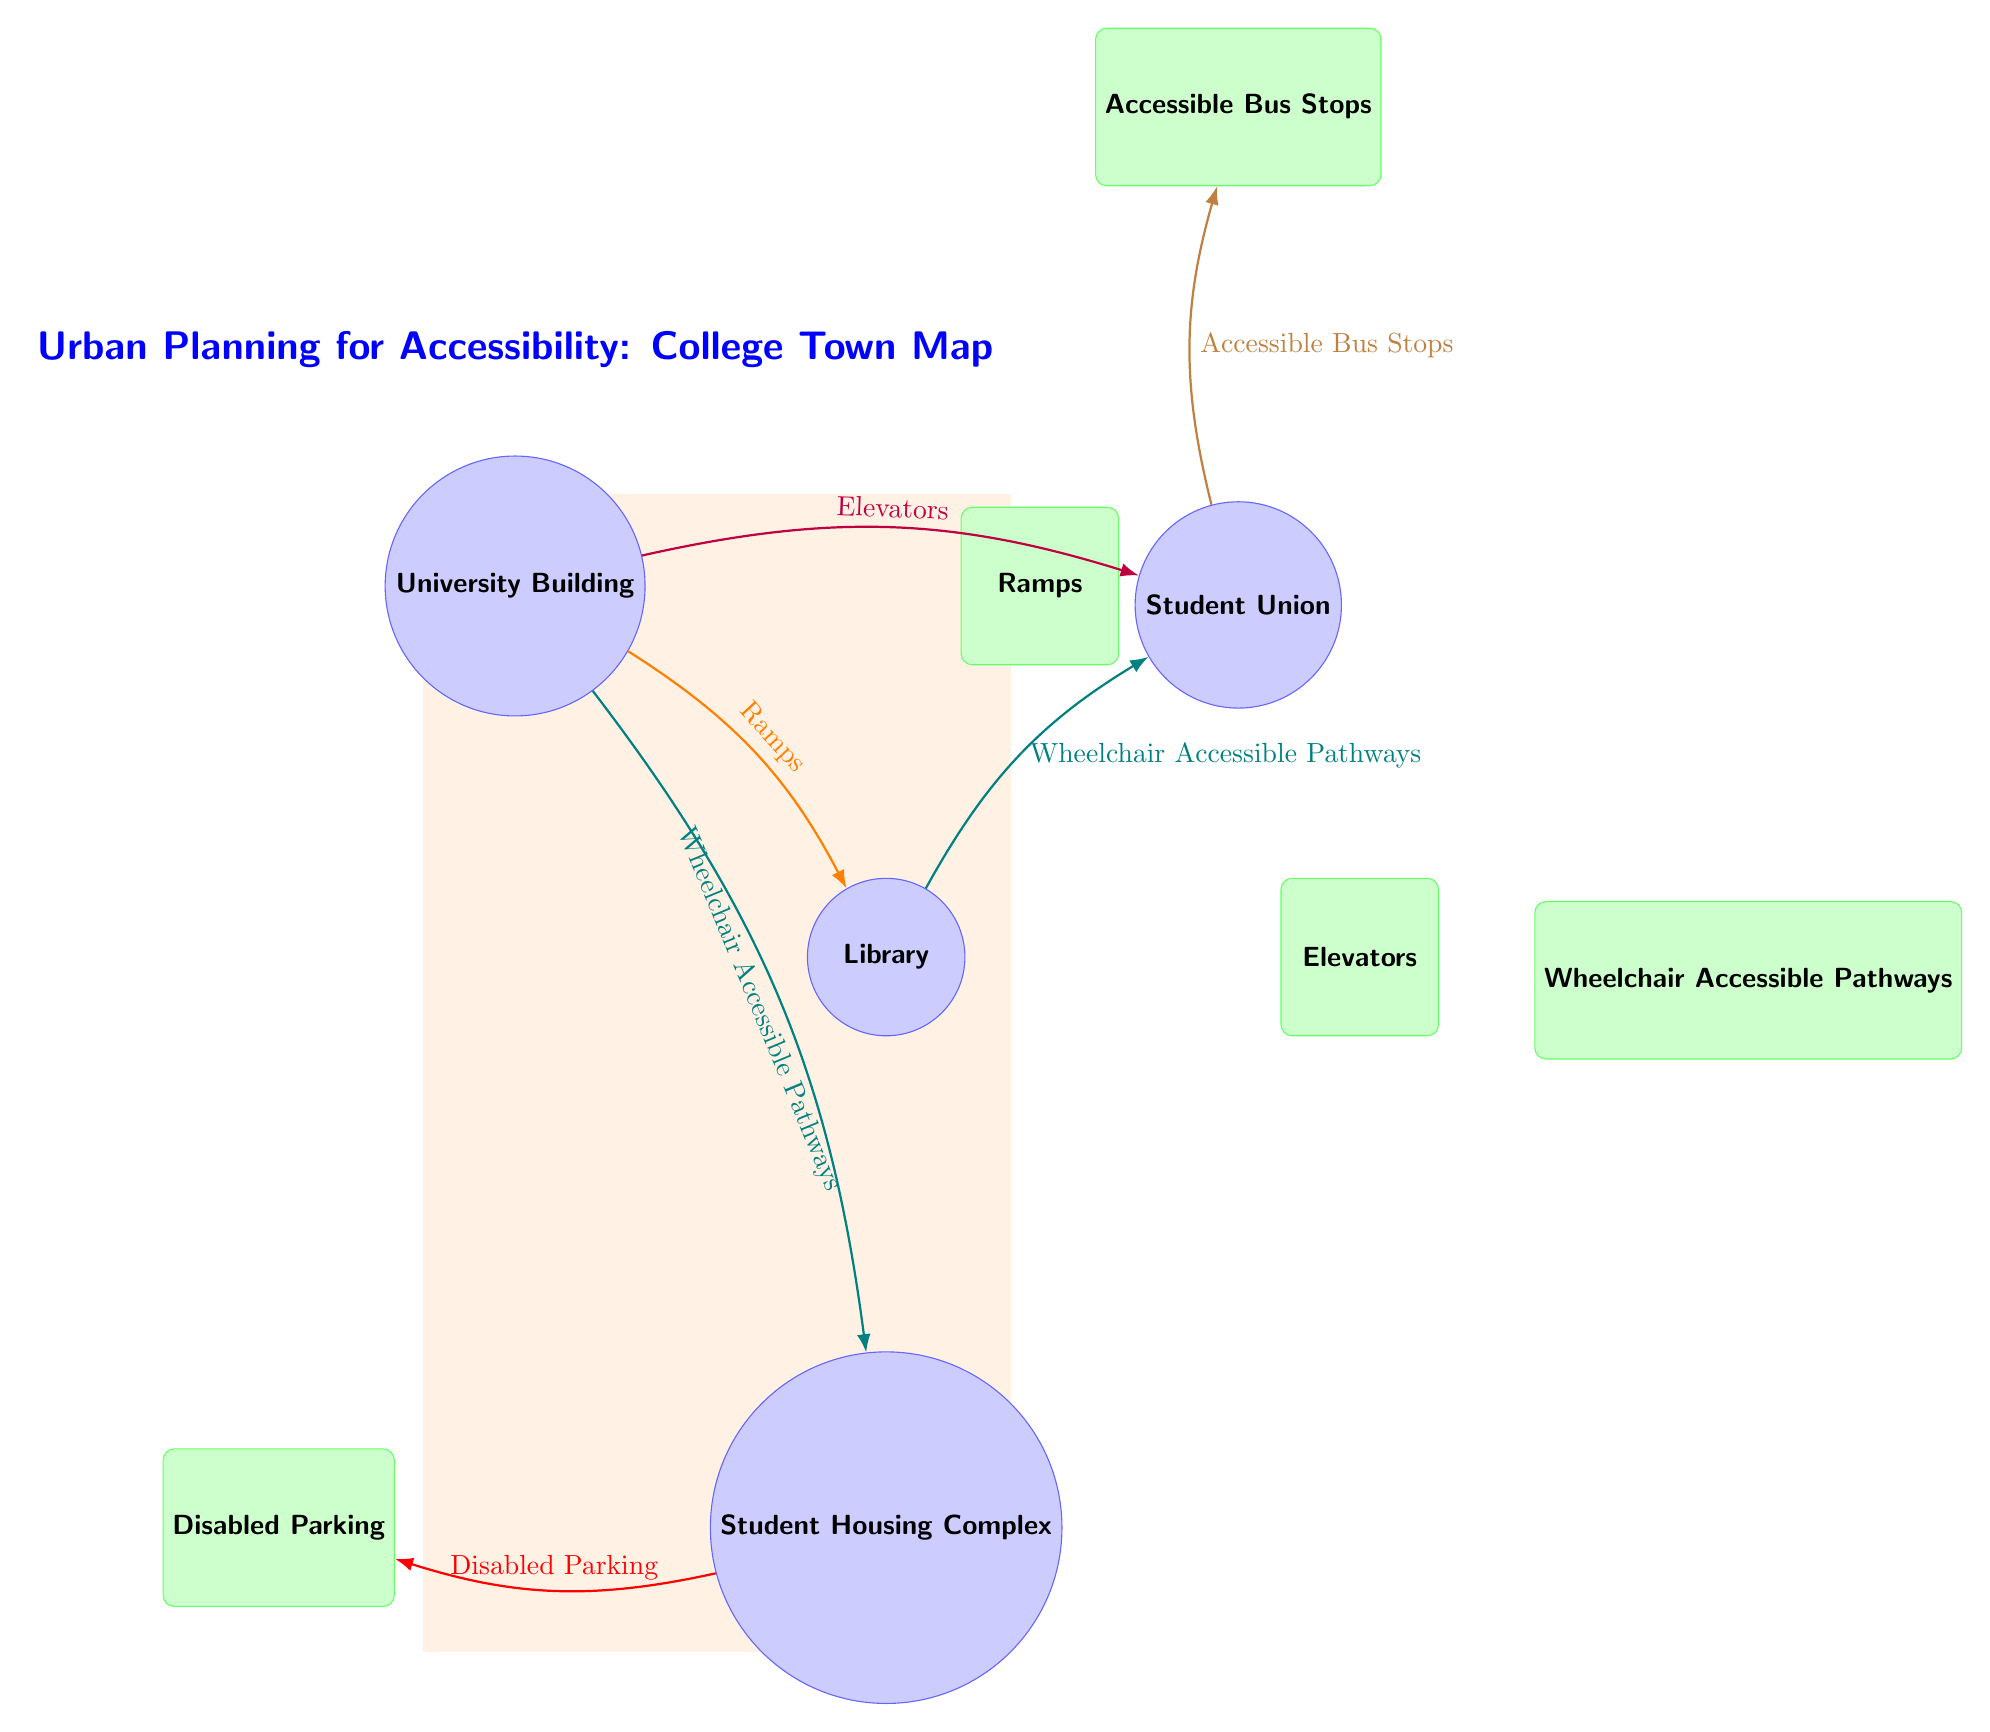What is the first location mentioned in the diagram? The first location node listed is the "University Building." This can be found at the top of the diagram as the initial node before any connections are drawn.
Answer: University Building How many locations are represented in the diagram? The diagram visually presents four distinct location nodes: University Building, Library, Student Union, and Student Housing Complex. By counting these nodes, we find there are four in total.
Answer: 4 What type of connection exists between the University Building and the Library? The connection from the University Building to the Library is denoted as "Ramps," which is represented with an orange arrow. This relationship shows how these two locations are interconnected for accessibility.
Answer: Ramps Which two locations have Wheelchair Accessible Pathways as connections? The Wheelchair Accessible Pathways connect Student Housing Complex to the University Building and the Library to the Student Union. These connections are shown in teal, indicating path availability between these nodes.
Answer: University Building, Student Union What infrastructure is connected to the Student Union? The infrastructure connected to the Student Union includes "Elevators" and "Accessible Bus Stops." Both connections indicate important facilities that enhance accessibility for individuals using this location.
Answer: Elevators, Accessible Bus Stops What infrastructure is located directly below the Library? Directly below the Library is the infrastructure labeled "Elevators." This is clearly indicated by the position in the diagram, showing its location concerning the Library.
Answer: Elevators Which location has a connection labeled "Disabled Parking"? The "Disabled Parking" connection originates from the Student Housing Complex, illustrating the access route available for those needing parking accommodations.
Answer: Student Housing Complex How are the locations of the Student Housing Complex and the Library connected? The Student Housing Complex and the Library are connected by the "Wheelchair Accessible Pathways." This connection, drawn in teal, indicates a straight path linking these locations together.
Answer: Wheelchair Accessible Pathways 